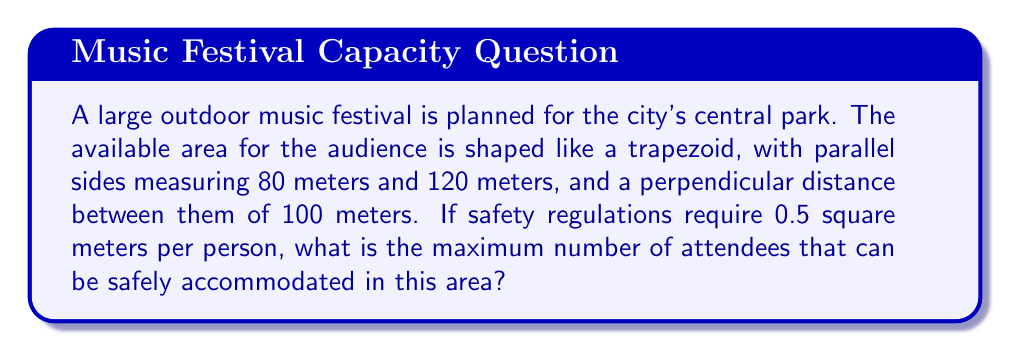Can you answer this question? To solve this problem, we'll follow these steps:

1) First, we need to calculate the area of the trapezoidal audience space. The formula for the area of a trapezoid is:

   $$A = \frac{1}{2}(a+b)h$$

   where $a$ and $b$ are the lengths of the parallel sides, and $h$ is the height (perpendicular distance between the parallel sides).

2) Substituting our values:
   
   $$A = \frac{1}{2}(80\text{ m} + 120\text{ m}) \times 100\text{ m}$$

3) Simplify:
   
   $$A = \frac{1}{2}(200\text{ m}) \times 100\text{ m} = 100\text{ m} \times 100\text{ m} = 10,000\text{ m}^2$$

4) Now that we have the total area, we need to determine how many people can fit in this space given the safety regulation of 0.5 square meters per person.

5) To find this, we divide the total area by the area required per person:

   $$\text{Number of people} = \frac{\text{Total area}}{\text{Area per person}} = \frac{10,000\text{ m}^2}{0.5\text{ m}^2/\text{person}}$$

6) Simplify:

   $$\text{Number of people} = 20,000$$

Therefore, the maximum number of attendees that can be safely accommodated is 20,000 people.
Answer: 20,000 people 